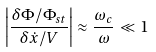Convert formula to latex. <formula><loc_0><loc_0><loc_500><loc_500>\left | \frac { \delta \Phi / \Phi _ { s t } } { \delta \dot { x } / V } \right | \approx \frac { \omega _ { c } } { \omega } \ll 1</formula> 